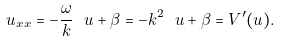<formula> <loc_0><loc_0><loc_500><loc_500>u _ { x x } = - \frac { \omega } { k } \ u + \beta = - k ^ { 2 } \ u + \beta = V ^ { \prime } ( u ) .</formula> 